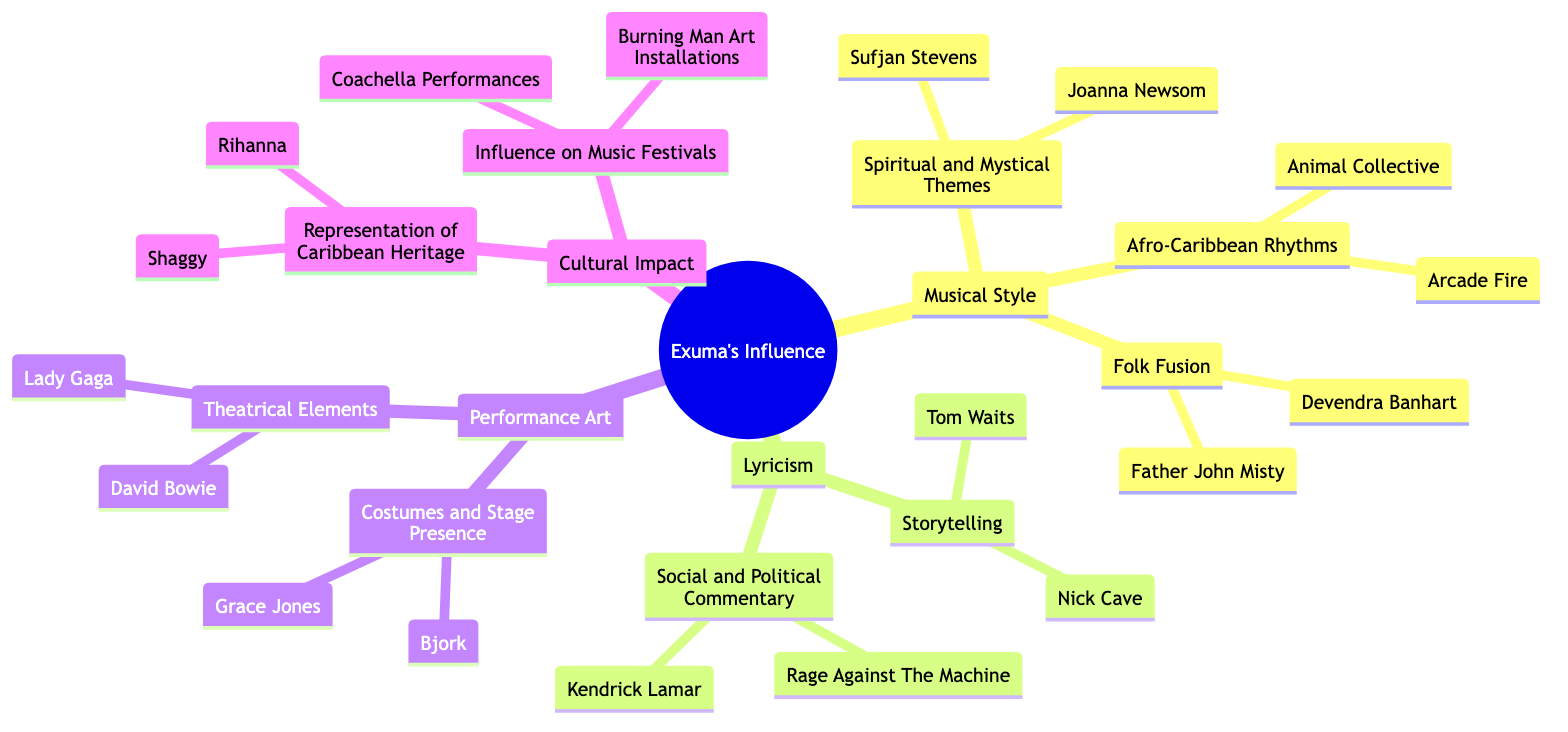What are the three subcategories under "Musical Style"? The diagram lists three subcategories under "Musical Style": Afro-Caribbean Rhythms, Folk Fusion, and Spiritual and Mystical Themes.
Answer: Afro-Caribbean Rhythms, Folk Fusion, Spiritual and Mystical Themes Who are the artists associated with "Storytelling"? The artists listed under the "Storytelling" category are Nick Cave and Tom Waits, as shown in the Lyricism section of the diagram.
Answer: Nick Cave, Tom Waits How many artists are mentioned in the "Performance Art" section? In the "Performance Art" section, there are four artists mentioned: David Bowie, Lady Gaga, Grace Jones, and Bjork, giving a total count of four.
Answer: 4 Which artist is associated with "Social and Political Commentary"? The artists listed under "Social and Political Commentary" include Kendrick Lamar and Rage Against The Machine, clearly indicated in the Lyricism part of the diagram.
Answer: Kendrick Lamar, Rage Against The Machine What themes are reflected in the "Cultural Impact" category? The "Cultural Impact" category reflects two themes: Representation of Caribbean Heritage and Influence on Music Festivals, which are specifically stated in the diagram.
Answer: Representation of Caribbean Heritage, Influence on Music Festivals How does Exuma influence contemporary artists regarding "Costumes and Stage Presence"? Under "Costumes and Stage Presence," the artists mentioned are Grace Jones and Bjork, indicating how Exuma's influence manifests through performance visuals in contemporary music.
Answer: Grace Jones, Bjork Name one contemporary artist influenced by "Spiritual and Mystical Themes." The diagram shows that Joanna Newsom is one of the contemporary artists influenced by "Spiritual and Mystical Themes," as categorized under Musical Style.
Answer: Joanna Newsom How many artists were influenced by the "Influence on Music Festivals"? The "Influence on Music Festivals" section notes Coachella Performances and Burning Man Art Installations, but does not list specific artists, thus the count is two notable events instead.
Answer: 2 